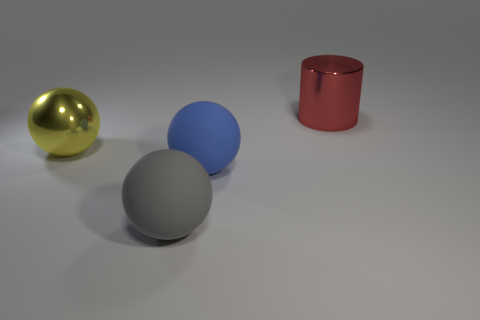There is a blue ball that is the same size as the gray matte ball; what material is it?
Your answer should be very brief. Rubber. How many big things are metal cylinders or gray things?
Your response must be concise. 2. Is the shape of the large yellow object the same as the blue rubber thing?
Your response must be concise. Yes. What number of things are both on the left side of the red shiny thing and right of the large gray matte object?
Ensure brevity in your answer.  1. Is there anything else that is the same color as the cylinder?
Make the answer very short. No. There is a big blue object that is made of the same material as the gray ball; what is its shape?
Make the answer very short. Sphere. Do the object behind the large metal ball and the yellow object have the same material?
Give a very brief answer. Yes. What number of blue things are on the left side of the big metal object on the right side of the large shiny object that is in front of the big metallic cylinder?
Your answer should be compact. 1. Does the big metallic thing that is in front of the cylinder have the same shape as the red metal object?
Your response must be concise. No. What number of things are red metallic cylinders or objects that are behind the yellow shiny thing?
Your answer should be compact. 1. 